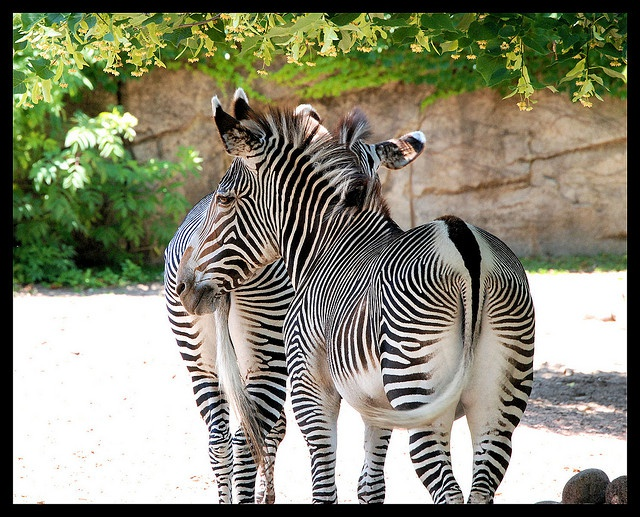Describe the objects in this image and their specific colors. I can see zebra in black, darkgray, lightgray, and gray tones and zebra in black, lightgray, darkgray, and gray tones in this image. 